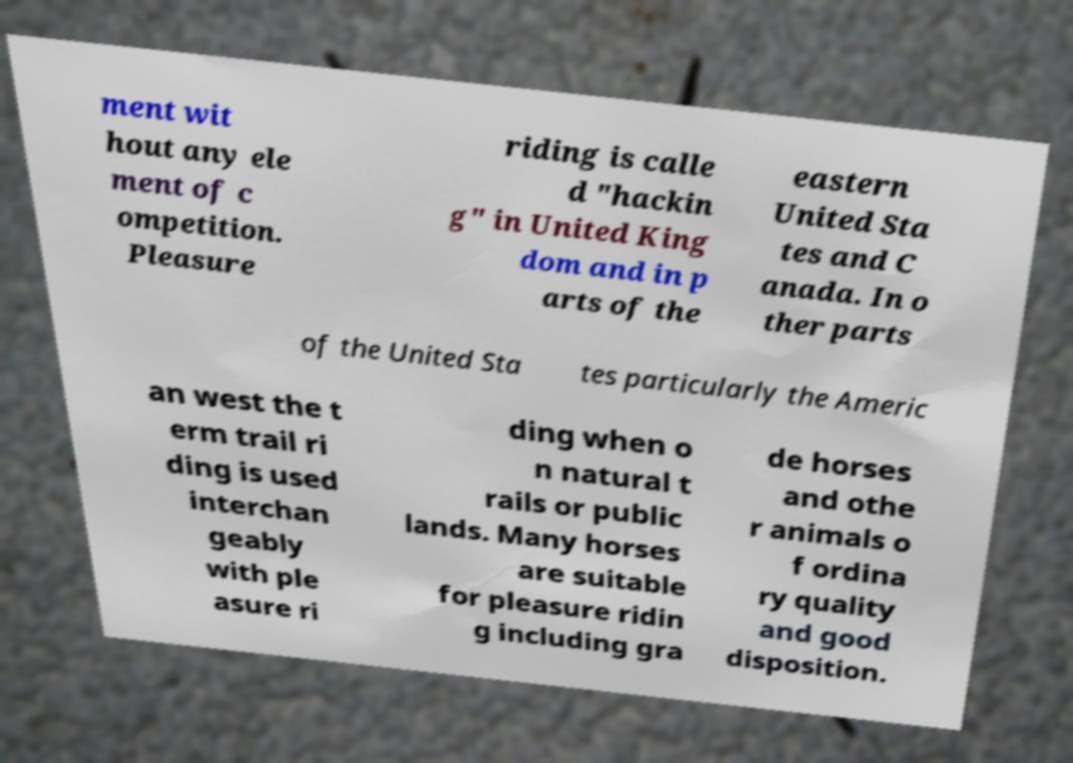There's text embedded in this image that I need extracted. Can you transcribe it verbatim? ment wit hout any ele ment of c ompetition. Pleasure riding is calle d "hackin g" in United King dom and in p arts of the eastern United Sta tes and C anada. In o ther parts of the United Sta tes particularly the Americ an west the t erm trail ri ding is used interchan geably with ple asure ri ding when o n natural t rails or public lands. Many horses are suitable for pleasure ridin g including gra de horses and othe r animals o f ordina ry quality and good disposition. 